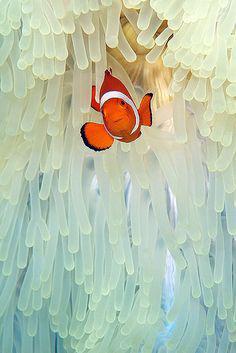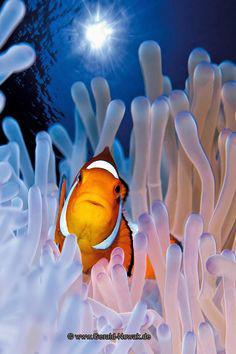The first image is the image on the left, the second image is the image on the right. Examine the images to the left and right. Is the description "the left and right image contains the same number of dogs clownfish." accurate? Answer yes or no. Yes. The first image is the image on the left, the second image is the image on the right. Considering the images on both sides, is "Each image shows one black-eyed clown fish within the white, slender tendrils of an anemone." valid? Answer yes or no. Yes. 